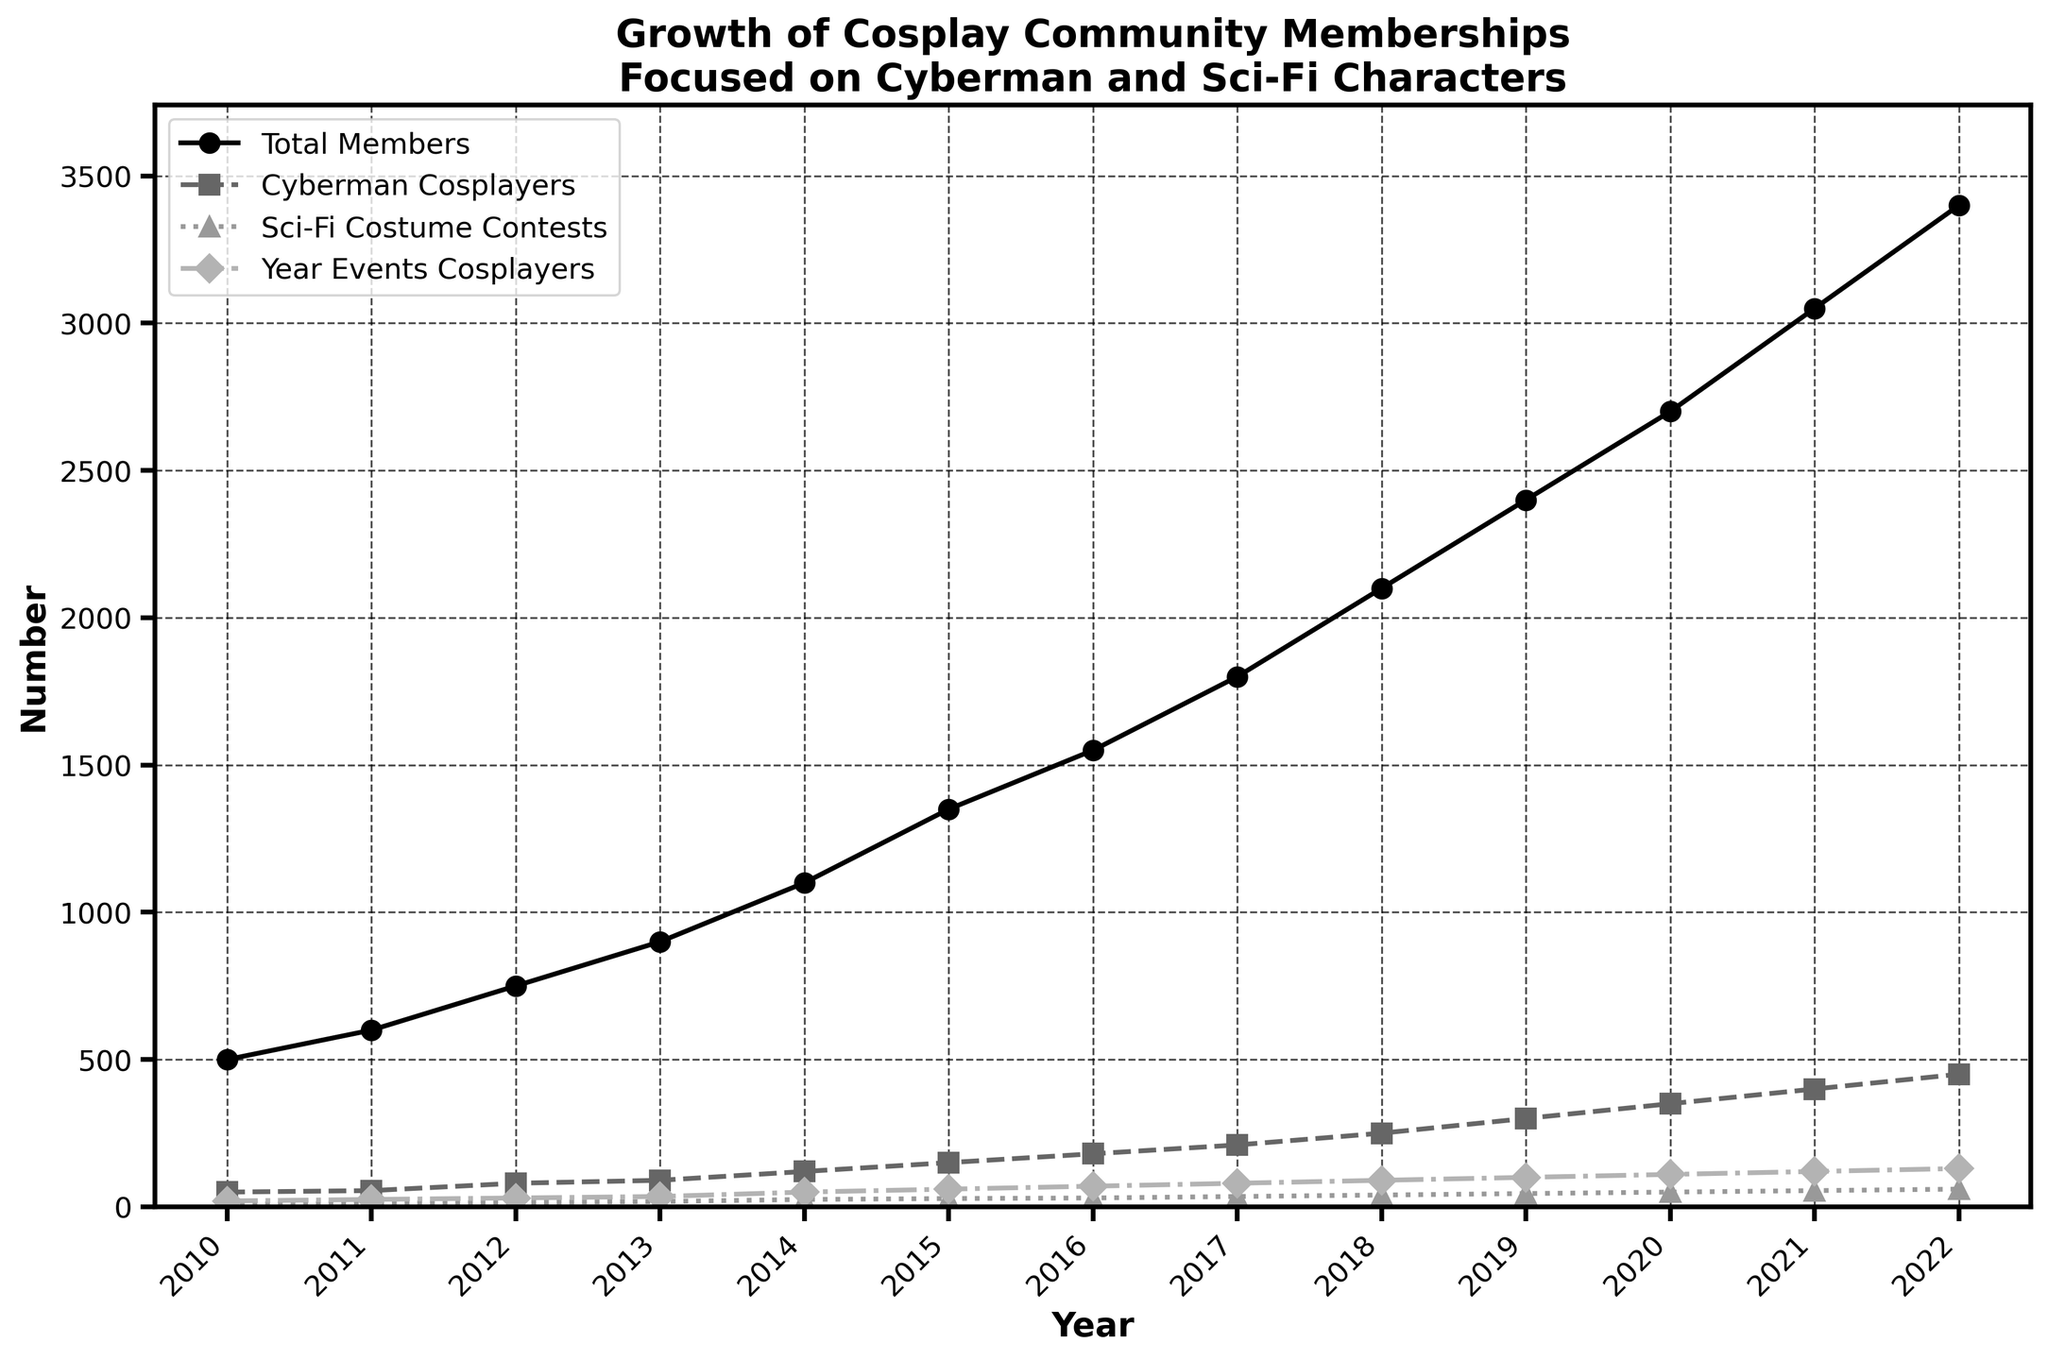What is the title of the figure? The title is typically displayed at the top of the figure. It should be the first text you see when you observe the chart.
Answer: Growth of Cosplay Community Memberships Focused on Cyberman and Sci-Fi Characters What does the x-axis represent? The x-axis runs horizontally across the bottom of the figure and represents the years in this plot.
Answer: Year Which line refers to the Cyberman Cosplayers? By checking the legend on the figure, you can identify the dashed line with square markers as representing Cyberman Cosplayers.
Answer: The dashed line with square markers How many members were there in 2015? Locate 2015 on the x-axis and follow the vertical line up to the 'Total Members' line (solid with circle markers), then read the corresponding y-axis value.
Answer: 1350 What was the trend in the number of Sci-Fi Costume Contests from 2010 to 2022? Follow the dotted line with triangle markers from the left to the right edge of the plot, observing that it consistently increases over the years.
Answer: Increasing trend How many Cyberman Cosplayers were there in 2020 and 2021 combined? Find the number of Cyberman Cosplayers in 2020 (350) and 2021 (400) from the dashed line with square markers, then add these two numbers. 350 + 400 = 750
Answer: 750 Which year shows the highest number of Year Events Cosplayers? Observe the dotted-dashed line with diamond markers and follow it to its peak, then correlate it with the x-axis year.
Answer: 2022 By how much did the total number of community members increase from 2010 to 2022? Determine the total members in 2010 (500) and 2022 (3400) using the solid line with circle markers, then subtract the former from the latter. 3400 - 500 = 2900
Answer: 2900 Do the Cyberman Cosplayers outnumber the Sci-Fi Costume Contests in every year? Compare the values of the dashed line with square markers (Cyberman Cosplayers) to the dotted line with triangle markers (Sci-Fi Costume Contests) for every year on the plot, ensuring Cyberman Cosplayers values are higher each year.
Answer: Yes Which year had equal numbers of total community members and Cyberman Cosplayers? Compare the solid line with circle markers (Total Members) and the dashed line with square markers (Cyberman Cosplayers) and see if they intersect at any point. Here they do not intersect.
Answer: No year 